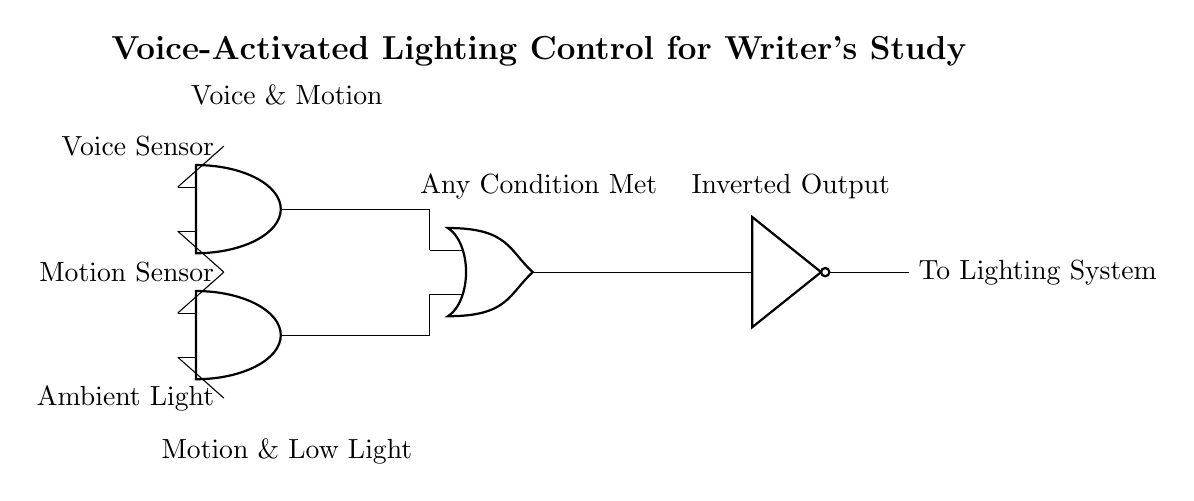What is the output of the NOT gate? The NOT gate inverts the output of the OR gate. If the OR gate receives an active high signal, the NOT gate will produce an active low signal. Thus, if any condition is met by the AND gates, the output of the NOT gate will be low.
Answer: Low How many AND gates are used in the circuit? The circuit contains two AND gates, positioned to accept inputs from the voice sensor, motion sensor, and ambient light sensor. Each AND gate processes different combinations of these inputs.
Answer: Two What conditions must be met for the OR gate to output a high signal? The OR gate outputs a high signal if at least one of its inputs receives a high signal from the preceding AND gates, which means either the voice and motion sensors are activated together, or the motion and low ambient light conditions are detected together.
Answer: One condition What happens when both motion and low light conditions are detected? When both conditions are detected, the relevant AND gate will output a high signal. This output then goes to the OR gate which, if combined with the first AND gate output being high, will result in the NOT gate inverting the OR gate output.
Answer: Output high What is the purpose of the motion sensor in this circuit? The motion sensor detects movement within the study, which is one of the inputs to both AND gates. Its function is crucial for both pathways that lead to activating the lighting system, making it an essential component of the circuit for triggering lights based on occupancy.
Answer: Detect movement 